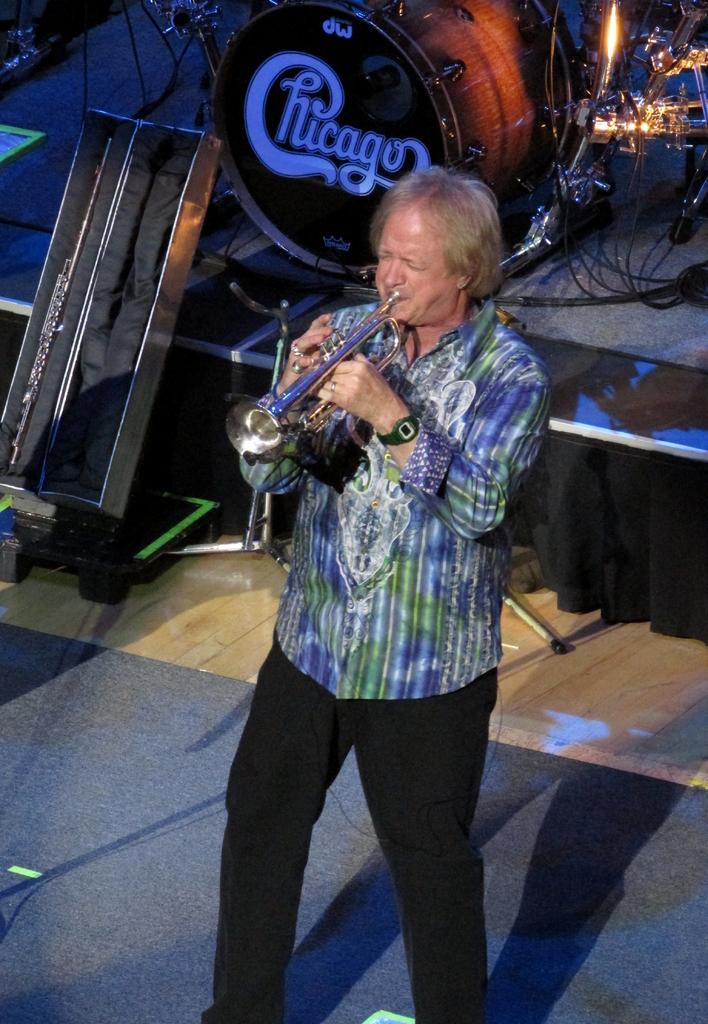What is the main subject of the image? There is a person in the image. What is the person holding in the image? The person is holding a musical instrument. What type of surface is visible in the image? There is a floor mat in the image. What is the setting of the image? There is a stage in the image. What can be seen illuminating the scene? There are lights in the image. What other objects can be seen in the image? There are other objects present in the image. What is the person's self-reflection on their ministerial duties in the image? There is no indication in the image of the person's self-reflection or ministerial duties, as the focus is on the person holding a musical instrument. What is the cause of the person's emotional state in the image? There is no indication of the person's emotional state in the image, as the focus is on the person holding a musical instrument. 